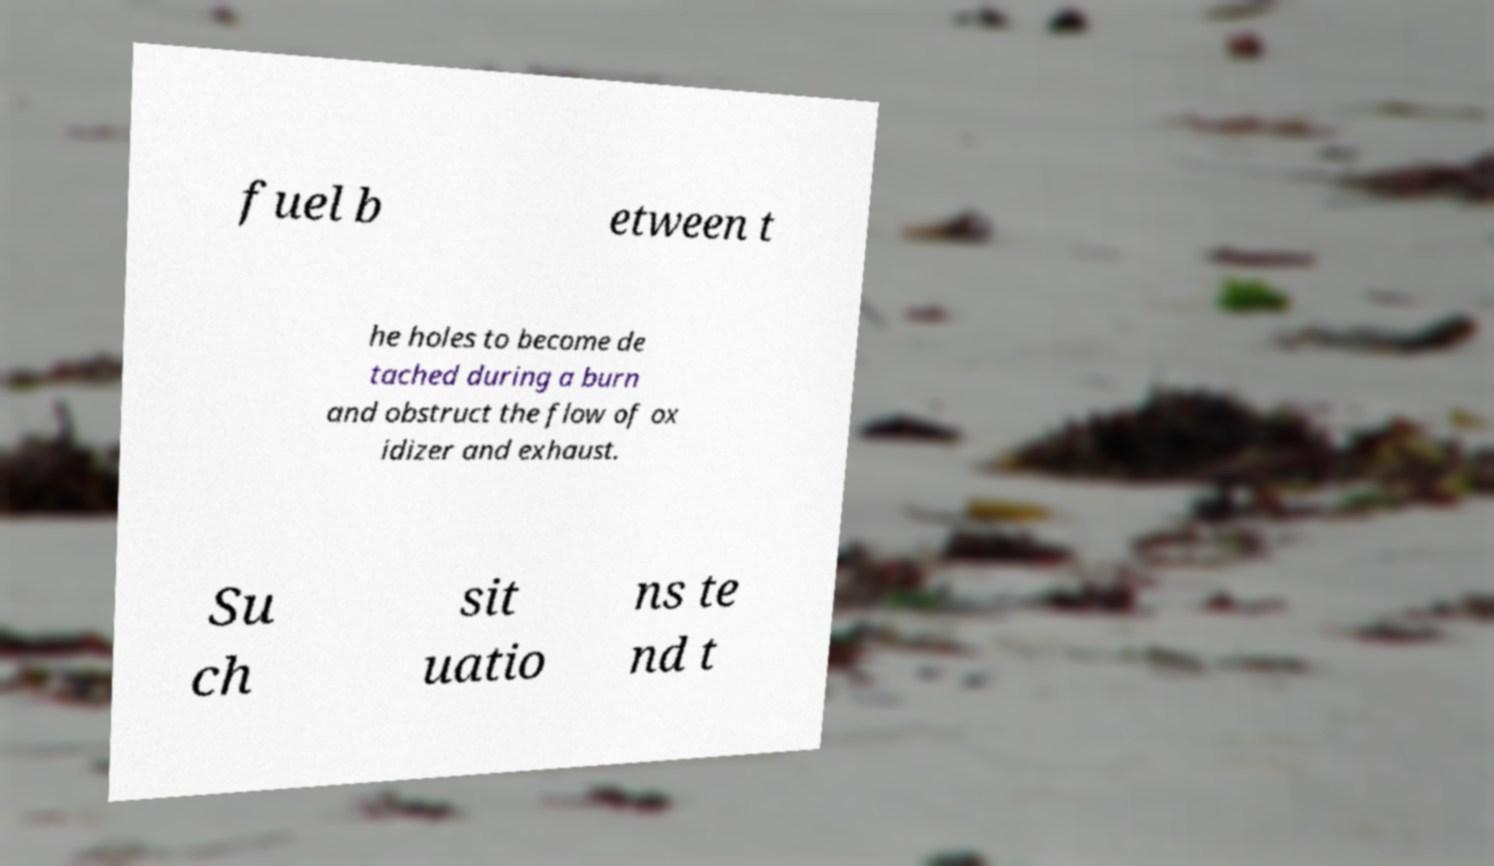Could you assist in decoding the text presented in this image and type it out clearly? fuel b etween t he holes to become de tached during a burn and obstruct the flow of ox idizer and exhaust. Su ch sit uatio ns te nd t 